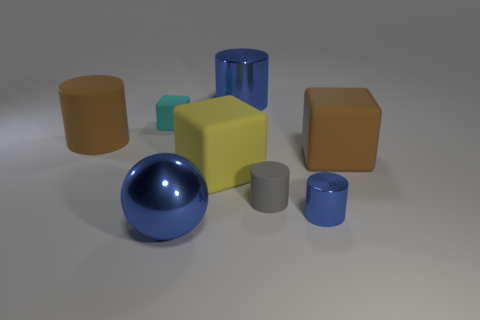Are there more metal balls on the right side of the large yellow rubber cube than gray blocks?
Make the answer very short. No. There is a matte thing that is behind the brown object left of the yellow block; what number of rubber things are right of it?
Provide a succinct answer. 3. Does the blue object behind the yellow rubber object have the same shape as the tiny blue shiny thing?
Keep it short and to the point. Yes. What is the material of the blue cylinder in front of the yellow cube?
Offer a terse response. Metal. What shape is the big rubber object that is right of the cyan matte cube and left of the small blue cylinder?
Make the answer very short. Cube. What is the tiny cyan object made of?
Your answer should be very brief. Rubber. How many spheres are either tiny rubber things or brown matte things?
Your response must be concise. 0. Is the yellow thing made of the same material as the small gray object?
Offer a very short reply. Yes. The brown matte object that is the same shape as the gray rubber thing is what size?
Give a very brief answer. Large. There is a small thing that is in front of the cyan matte object and behind the tiny blue metal thing; what material is it made of?
Your answer should be very brief. Rubber. 